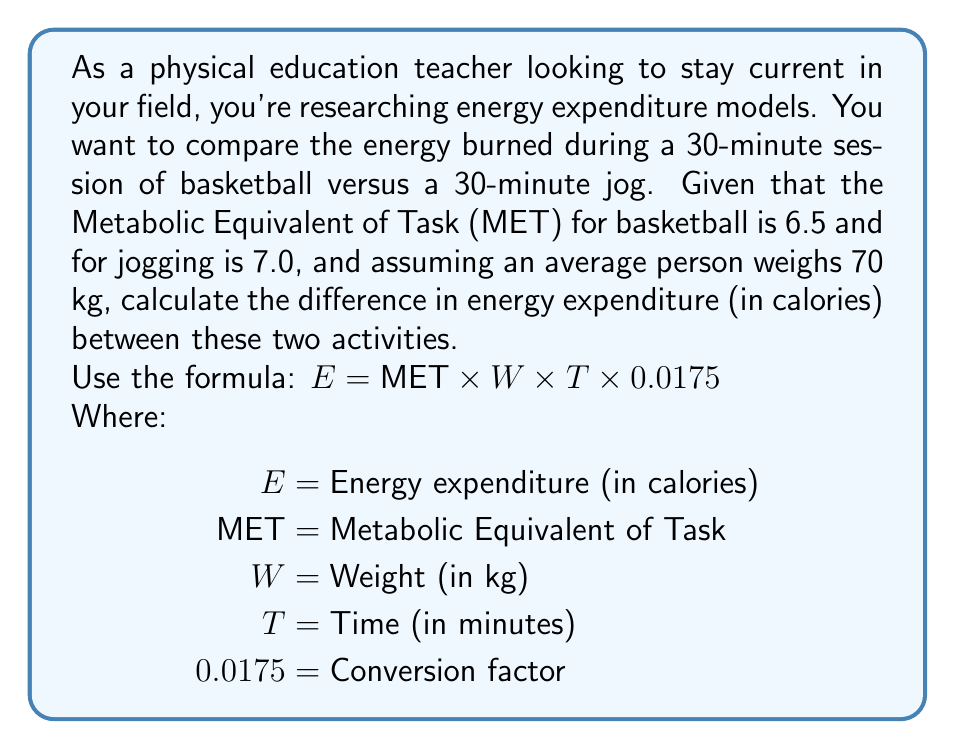Can you answer this question? To solve this problem, we'll calculate the energy expenditure for each activity and then find the difference.

1. For basketball:
   $$E_{basketball} = 6.5 \times 70 \times 30 \times 0.0175 = 239.75 \text{ calories}$$

2. For jogging:
   $$E_{jogging} = 7.0 \times 70 \times 30 \times 0.0175 = 257.25 \text{ calories}$$

3. Calculate the difference:
   $$\Delta E = E_{jogging} - E_{basketball} = 257.25 - 239.75 = 17.5 \text{ calories}$$

The difference in energy expenditure is 17.5 calories, with jogging burning more calories than basketball in this 30-minute session.

This calculation demonstrates how mathematical models can be used to estimate and compare energy expenditure for different physical activities, which is valuable knowledge for a physical education teacher.
Answer: 17.5 calories 